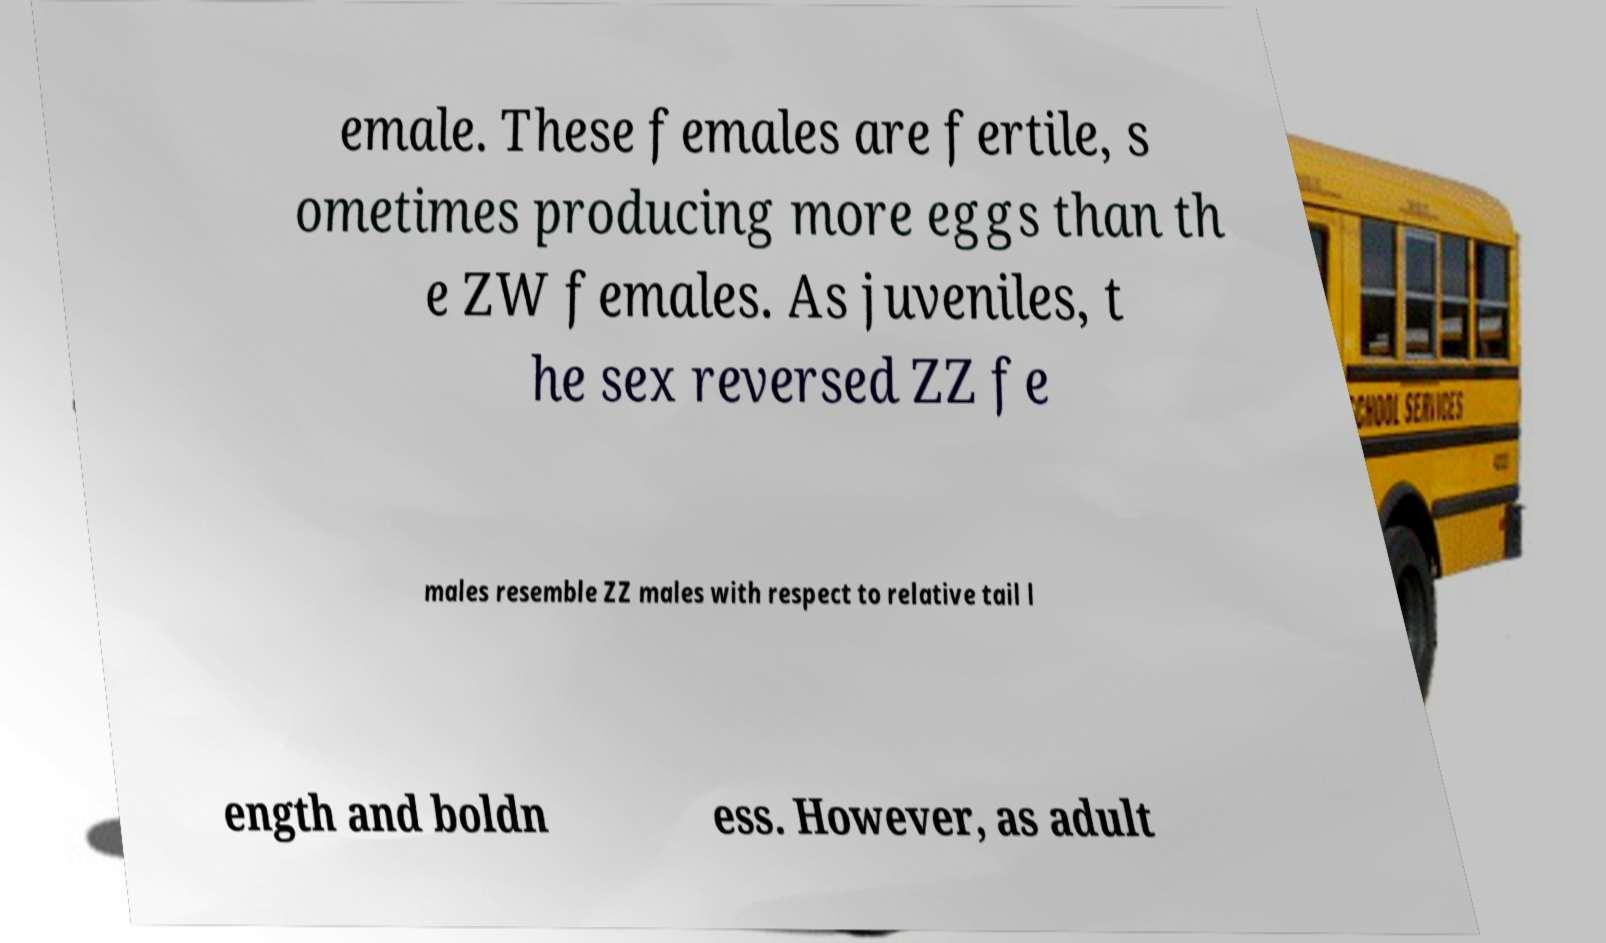Please read and relay the text visible in this image. What does it say? emale. These females are fertile, s ometimes producing more eggs than th e ZW females. As juveniles, t he sex reversed ZZ fe males resemble ZZ males with respect to relative tail l ength and boldn ess. However, as adult 